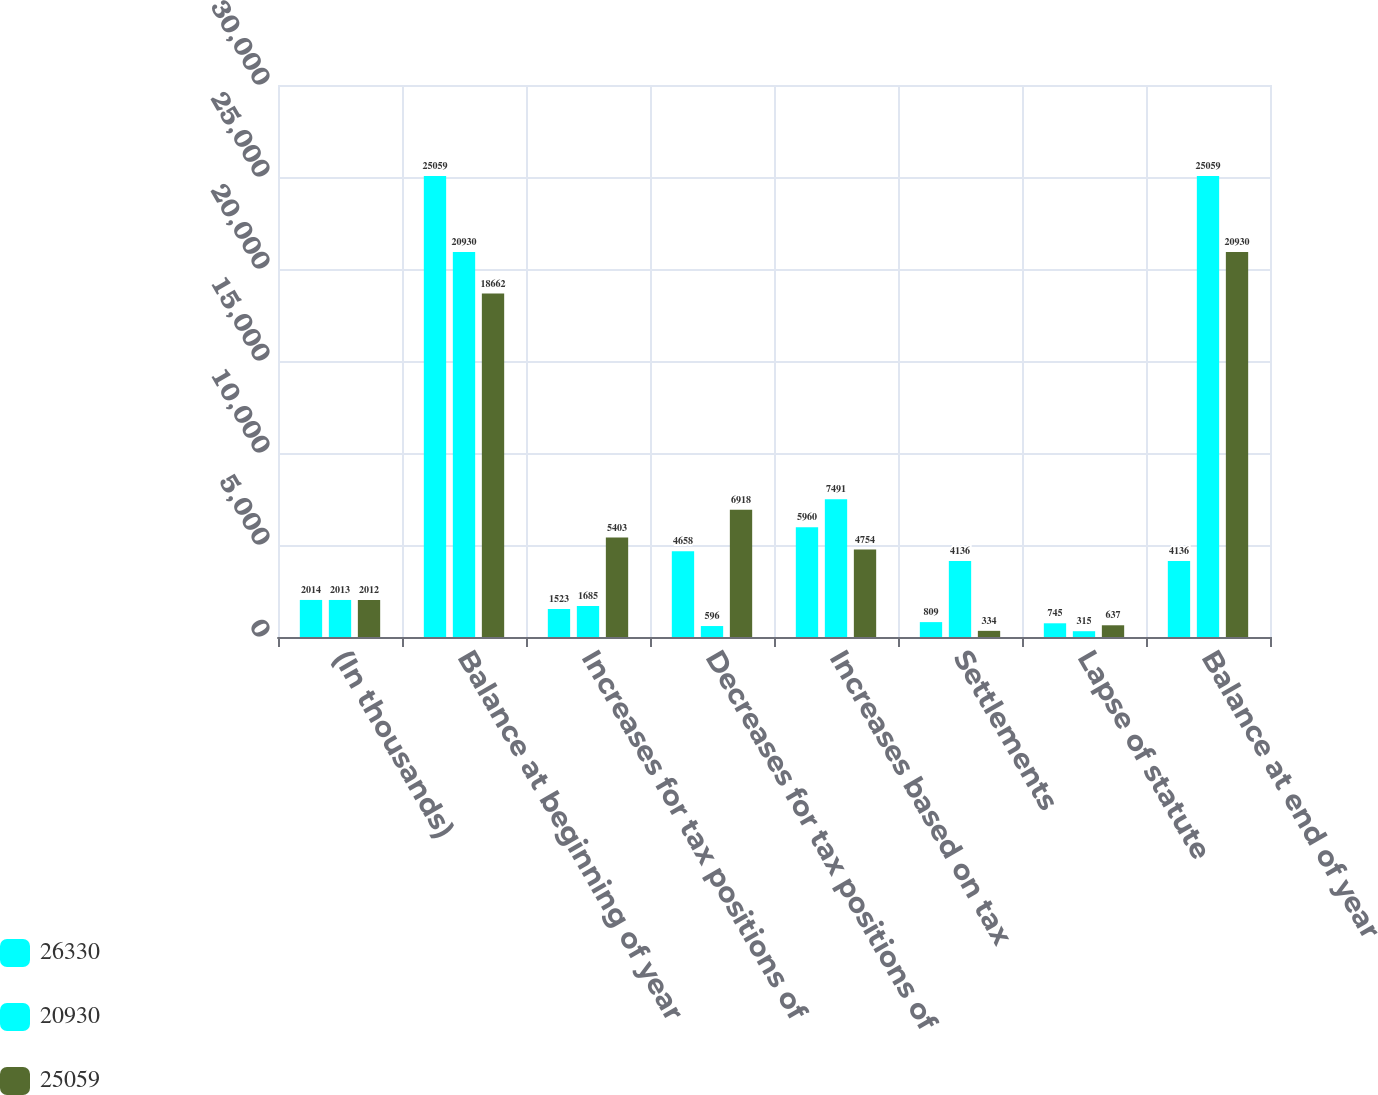<chart> <loc_0><loc_0><loc_500><loc_500><stacked_bar_chart><ecel><fcel>(In thousands)<fcel>Balance at beginning of year<fcel>Increases for tax positions of<fcel>Decreases for tax positions of<fcel>Increases based on tax<fcel>Settlements<fcel>Lapse of statute<fcel>Balance at end of year<nl><fcel>26330<fcel>2014<fcel>25059<fcel>1523<fcel>4658<fcel>5960<fcel>809<fcel>745<fcel>4136<nl><fcel>20930<fcel>2013<fcel>20930<fcel>1685<fcel>596<fcel>7491<fcel>4136<fcel>315<fcel>25059<nl><fcel>25059<fcel>2012<fcel>18662<fcel>5403<fcel>6918<fcel>4754<fcel>334<fcel>637<fcel>20930<nl></chart> 